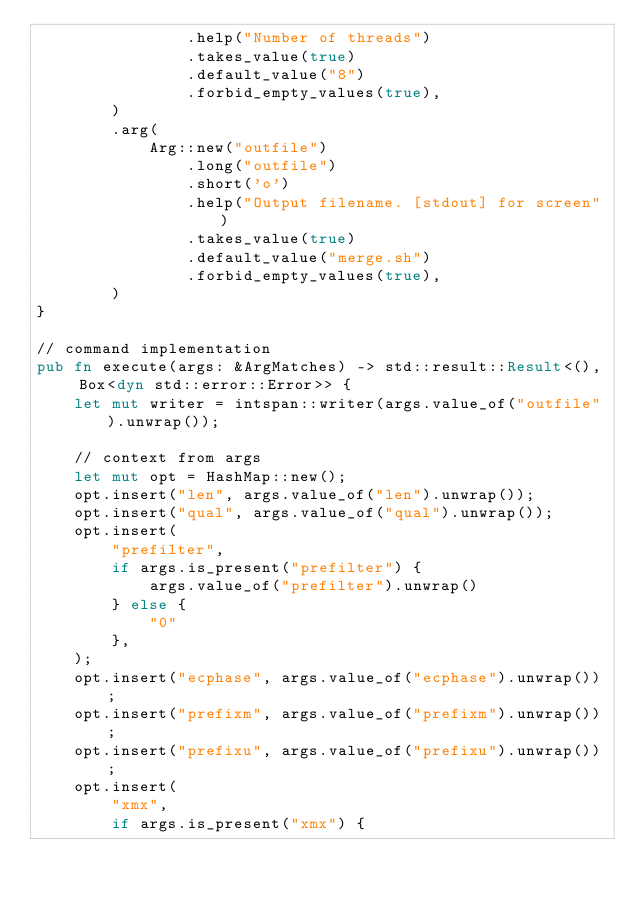Convert code to text. <code><loc_0><loc_0><loc_500><loc_500><_Rust_>                .help("Number of threads")
                .takes_value(true)
                .default_value("8")
                .forbid_empty_values(true),
        )
        .arg(
            Arg::new("outfile")
                .long("outfile")
                .short('o')
                .help("Output filename. [stdout] for screen")
                .takes_value(true)
                .default_value("merge.sh")
                .forbid_empty_values(true),
        )
}

// command implementation
pub fn execute(args: &ArgMatches) -> std::result::Result<(), Box<dyn std::error::Error>> {
    let mut writer = intspan::writer(args.value_of("outfile").unwrap());

    // context from args
    let mut opt = HashMap::new();
    opt.insert("len", args.value_of("len").unwrap());
    opt.insert("qual", args.value_of("qual").unwrap());
    opt.insert(
        "prefilter",
        if args.is_present("prefilter") {
            args.value_of("prefilter").unwrap()
        } else {
            "0"
        },
    );
    opt.insert("ecphase", args.value_of("ecphase").unwrap());
    opt.insert("prefixm", args.value_of("prefixm").unwrap());
    opt.insert("prefixu", args.value_of("prefixu").unwrap());
    opt.insert(
        "xmx",
        if args.is_present("xmx") {</code> 